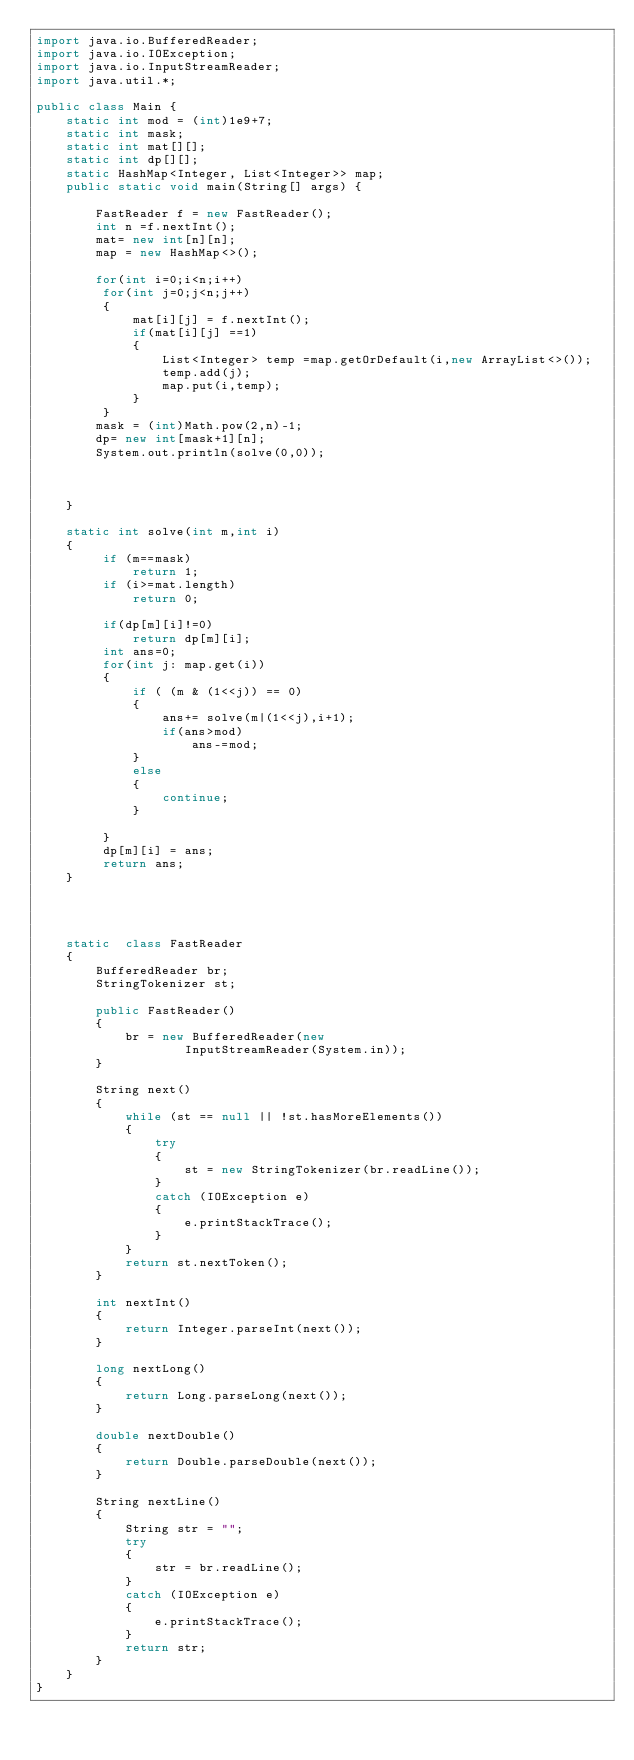<code> <loc_0><loc_0><loc_500><loc_500><_Java_>import java.io.BufferedReader;
import java.io.IOException;
import java.io.InputStreamReader;
import java.util.*;

public class Main {
    static int mod = (int)1e9+7;
    static int mask;
    static int mat[][];
    static int dp[][];
    static HashMap<Integer, List<Integer>> map;
    public static void main(String[] args) {

        FastReader f = new FastReader();
        int n =f.nextInt();
        mat= new int[n][n];
        map = new HashMap<>();

        for(int i=0;i<n;i++)
         for(int j=0;j<n;j++)
         {
             mat[i][j] = f.nextInt();
             if(mat[i][j] ==1)
             {
                 List<Integer> temp =map.getOrDefault(i,new ArrayList<>());
                 temp.add(j);
                 map.put(i,temp);
             }
         }
        mask = (int)Math.pow(2,n)-1;
        dp= new int[mask+1][n];
        System.out.println(solve(0,0));



    }

    static int solve(int m,int i)
    {
         if (m==mask)
             return 1;
         if (i>=mat.length)
             return 0;

         if(dp[m][i]!=0)
             return dp[m][i];
         int ans=0;
         for(int j: map.get(i))
         {
             if ( (m & (1<<j)) == 0)
             {
                 ans+= solve(m|(1<<j),i+1);
                 if(ans>mod)
                     ans-=mod;
             }
             else
             {
                 continue;
             }

         }
         dp[m][i] = ans;
         return ans;
    }




    static  class FastReader
    {
        BufferedReader br;
        StringTokenizer st;

        public FastReader()
        {
            br = new BufferedReader(new
                    InputStreamReader(System.in));
        }

        String next()
        {
            while (st == null || !st.hasMoreElements())
            {
                try
                {
                    st = new StringTokenizer(br.readLine());
                }
                catch (IOException e)
                {
                    e.printStackTrace();
                }
            }
            return st.nextToken();
        }

        int nextInt()
        {
            return Integer.parseInt(next());
        }

        long nextLong()
        {
            return Long.parseLong(next());
        }

        double nextDouble()
        {
            return Double.parseDouble(next());
        }

        String nextLine()
        {
            String str = "";
            try
            {
                str = br.readLine();
            }
            catch (IOException e)
            {
                e.printStackTrace();
            }
            return str;
        }
    }
}
</code> 